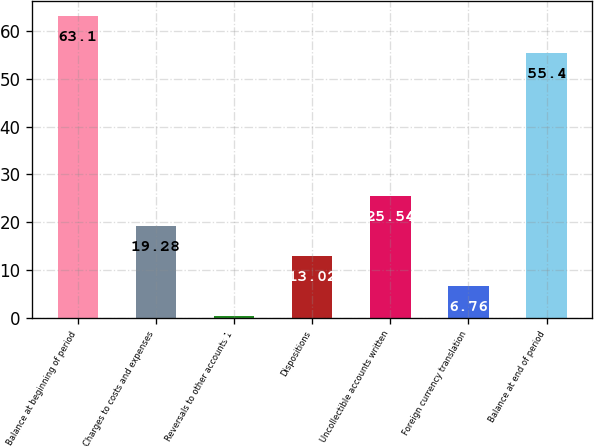Convert chart. <chart><loc_0><loc_0><loc_500><loc_500><bar_chart><fcel>Balance at beginning of period<fcel>Charges to costs and expenses<fcel>Reversals to other accounts 1<fcel>Dispositions<fcel>Uncollectible accounts written<fcel>Foreign currency translation<fcel>Balance at end of period<nl><fcel>63.1<fcel>19.28<fcel>0.5<fcel>13.02<fcel>25.54<fcel>6.76<fcel>55.4<nl></chart> 